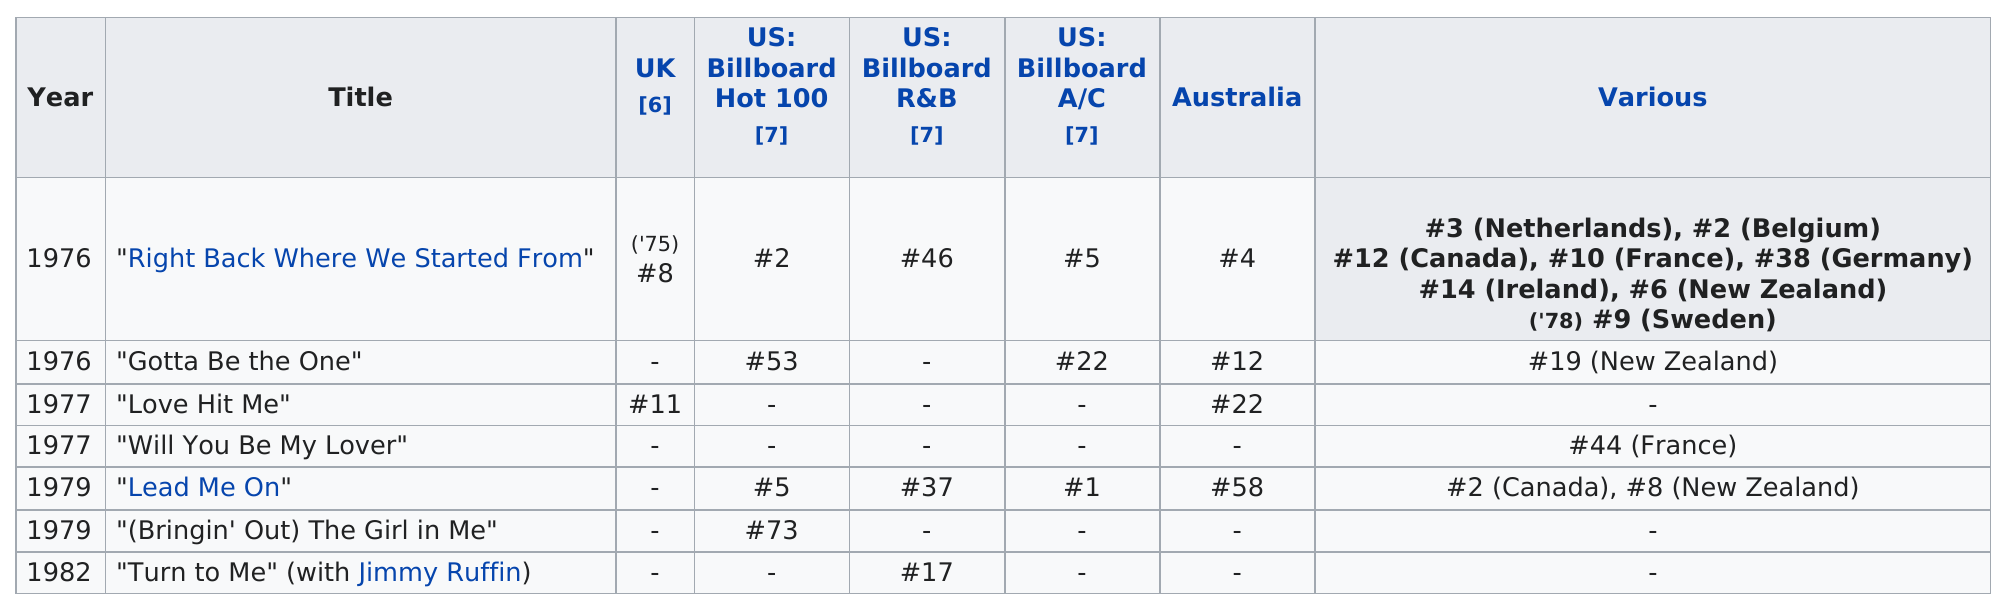Identify some key points in this picture. Lead Me On" appeared on a total of 6 charts. The song 'Love Hit Me' did not appear on the Billboard Hot 100 chart. Turn to Me" was higher on the R&B chart than "Lead Me On. In 1976, the artist had the most charted singles. In 1979, the song "Lead Me On" did not chart in the UK. 